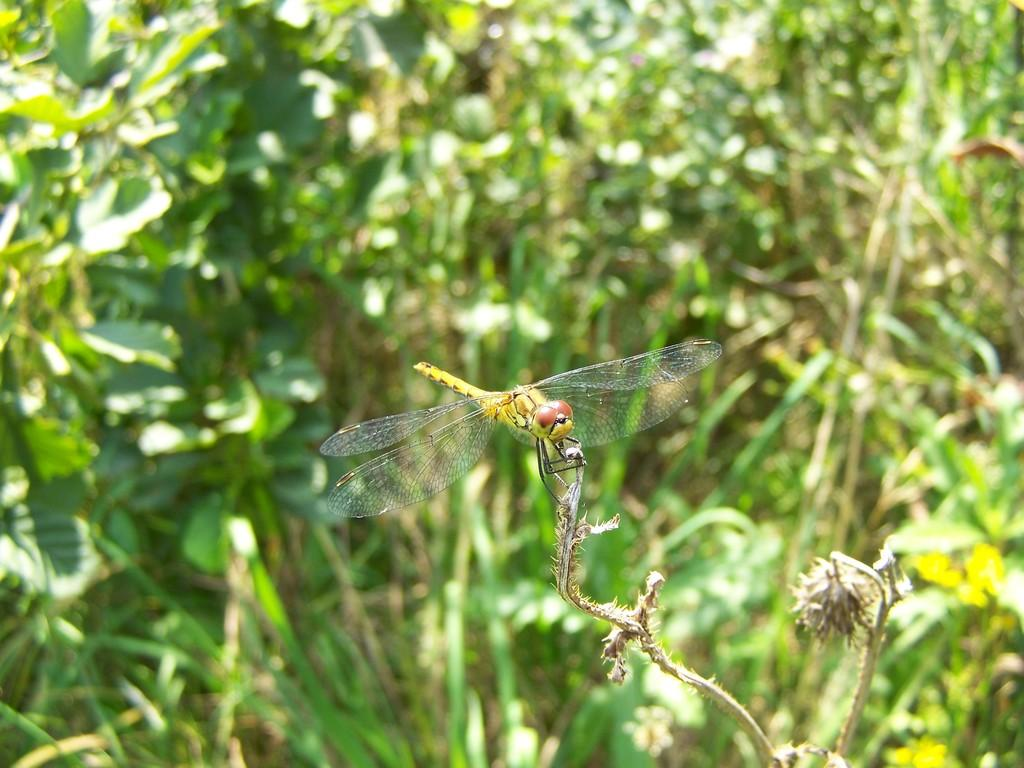What insect can be seen in the picture? There is a dragonfly in the picture. What is the dragonfly resting on? The dragonfly is on a brown object. Can you describe the background of the image? The background of the image is blurred. What type of vegetation is visible in the image? There are plants visible in the image. Is there a parcel being delivered by the dragonfly in the image? No, there is no parcel present in the image, and the dragonfly is not delivering anything. 